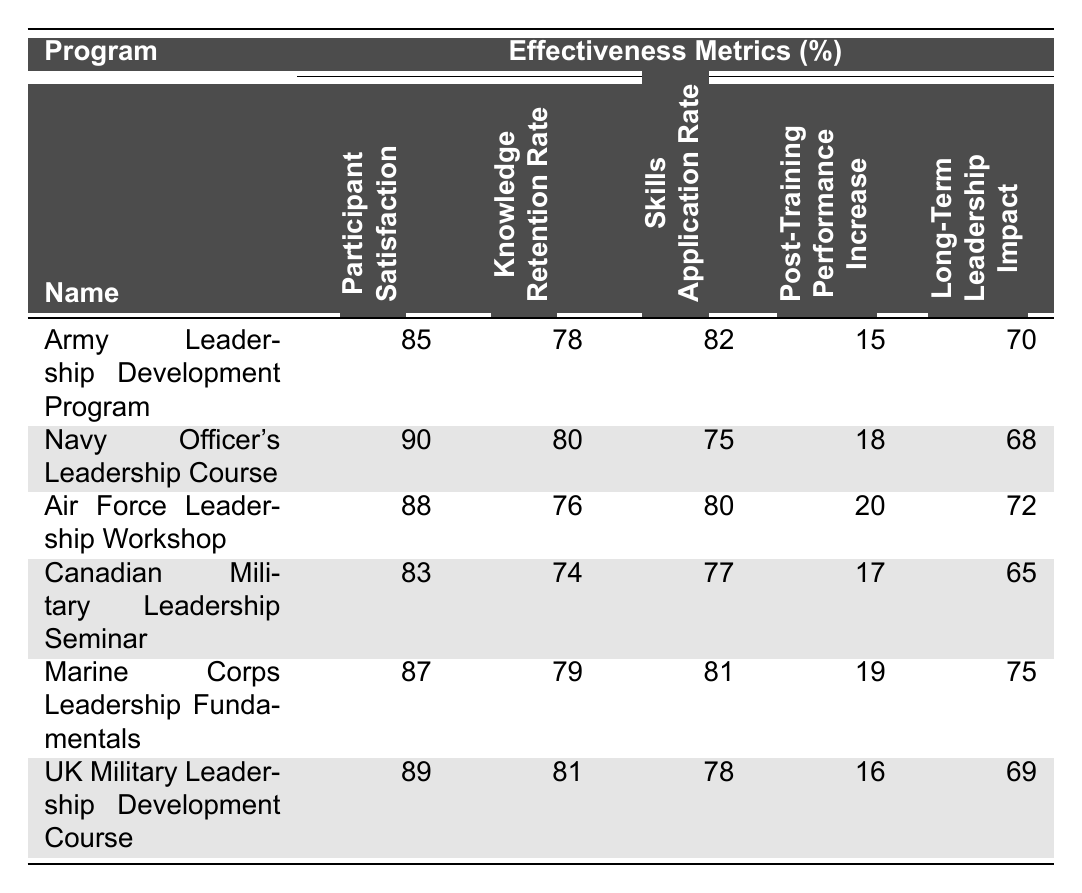What is the participant satisfaction rate for the Air Force Leadership Workshop? The table shows that the participant satisfaction rate for the Air Force Leadership Workshop is 88%.
Answer: 88% Which program has the highest Knowledge Retention Rate? The Navy Officer's Leadership Course has the highest Knowledge Retention Rate at 80%.
Answer: 80% What is the Post-Training Performance Increase for the Marine Corps Leadership Fundamentals? According to the table, the Post-Training Performance Increase for the Marine Corps Leadership Fundamentals is 19%.
Answer: 19% What is the average Skills Application Rate across all programs? To calculate the average, add all Rates: (82 + 75 + 80 + 77 + 81 + 78) = 473, then divide by 6 (total programs). The average is 473 / 6 = 78.83.
Answer: 78.83 Which program shows a Long-Term Leadership Impact of at least 70%? The Army Leadership Development Program, Marine Corps Leadership Fundamentals, and Air Force Leadership Workshop all have a Long-Term Leadership Impact of at least 70%.
Answer: Yes Is there a program where the Post-Training Performance Increase is less than the Participant Satisfaction rate? Yes, in the case of the UK Military Leadership Development Course, the Post-Training Performance Increase is 16%, which is less than the Participant Satisfaction rate of 89%.
Answer: Yes What is the difference between the Participant Satisfaction rates of the Army Leadership Development Program and the Navy Officer's Leadership Course? The difference can be found by subtracting: 90 (Navy) - 85 (Army) = 5.
Answer: 5 Calculate the median Long-Term Leadership Impact of the programs. Arrange the Long-Term Leadership Impact values: 65, 68, 69, 70, 72, 75. Since there are 6 values, the median is the average of the 3rd and 4th values: (69 + 70) / 2 = 69.5.
Answer: 69.5 Do the results indicate that the Navy Officer's Leadership Course has a higher Skills Application Rate than the Air Force Leadership Workshop? Yes, the Navy Officer's Leadership Course has a Skills Application Rate of 75%, while the Air Force Leadership Workshop has a rate of 80%, which is higher.
Answer: No What is the overall trend in Participant Satisfaction for the military programs displayed? The trends show that scores for Participant Satisfaction range from 83% to 90%, indicating a generally high level of satisfaction across the programs.
Answer: Generally high satisfaction 